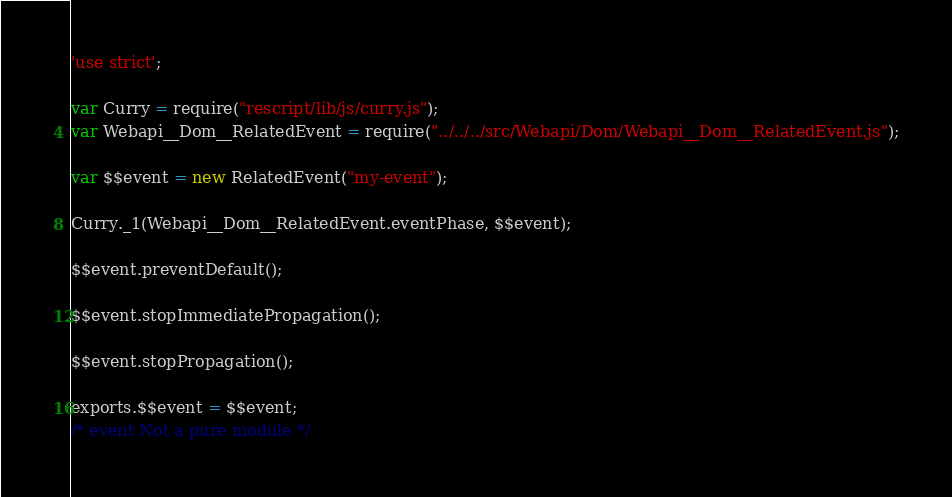<code> <loc_0><loc_0><loc_500><loc_500><_JavaScript_>'use strict';

var Curry = require("rescript/lib/js/curry.js");
var Webapi__Dom__RelatedEvent = require("../../../src/Webapi/Dom/Webapi__Dom__RelatedEvent.js");

var $$event = new RelatedEvent("my-event");

Curry._1(Webapi__Dom__RelatedEvent.eventPhase, $$event);

$$event.preventDefault();

$$event.stopImmediatePropagation();

$$event.stopPropagation();

exports.$$event = $$event;
/* event Not a pure module */
</code> 